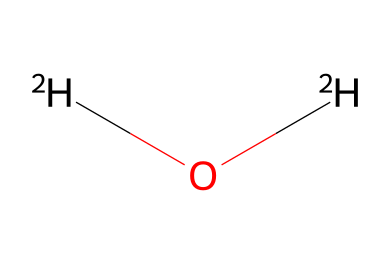What is the chemical name of [2H]O[2H]? The chemical structure represents heavy water, which consists of deuterium instead of regular hydrogen. The presence of deuterium is indicated by the notation [2H].
Answer: heavy water How many total atoms are in heavy water? The structure [2H]O[2H] indicates there are two deuterium atoms and one oxygen atom, amounting to a total of three atoms.
Answer: three What type of bond connects the deuterium and oxygen in heavy water? In the structure, each deuterium atom is bonded to the oxygen atom by a covalent bond. This is a characteristic of water and its isotopes.
Answer: covalent bond What is the significance of deuterium in heavy water? Deuterium, as an isotope of hydrogen, has an extra neutron which contributes to the unique properties of heavy water, including its use in nuclear reactors as a moderator.
Answer: isotope properties What is the molecular formula of deuterium oxide? The molecular structure [2H]O[2H] translates to the formula D2O, where D stands for deuterium and O stands for oxygen, indicating two deuterium atoms.
Answer: D2O How does the boiling point of heavy water compare to regular water? Heavy water has a higher boiling point than regular water (H2O) due to the increased mass from deuterium, which affects its physical properties.
Answer: higher boiling point 